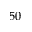Convert formula to latex. <formula><loc_0><loc_0><loc_500><loc_500>5 0</formula> 